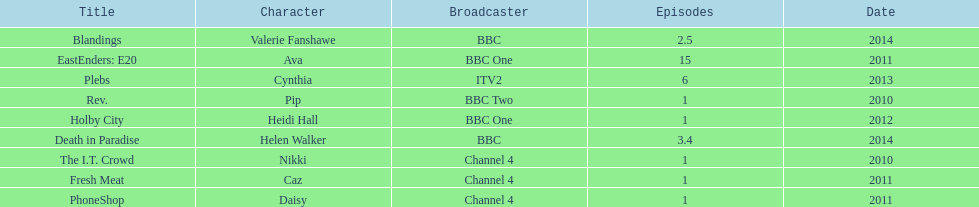Which broadcaster hosted 3 titles but they had only 1 episode? Channel 4. 